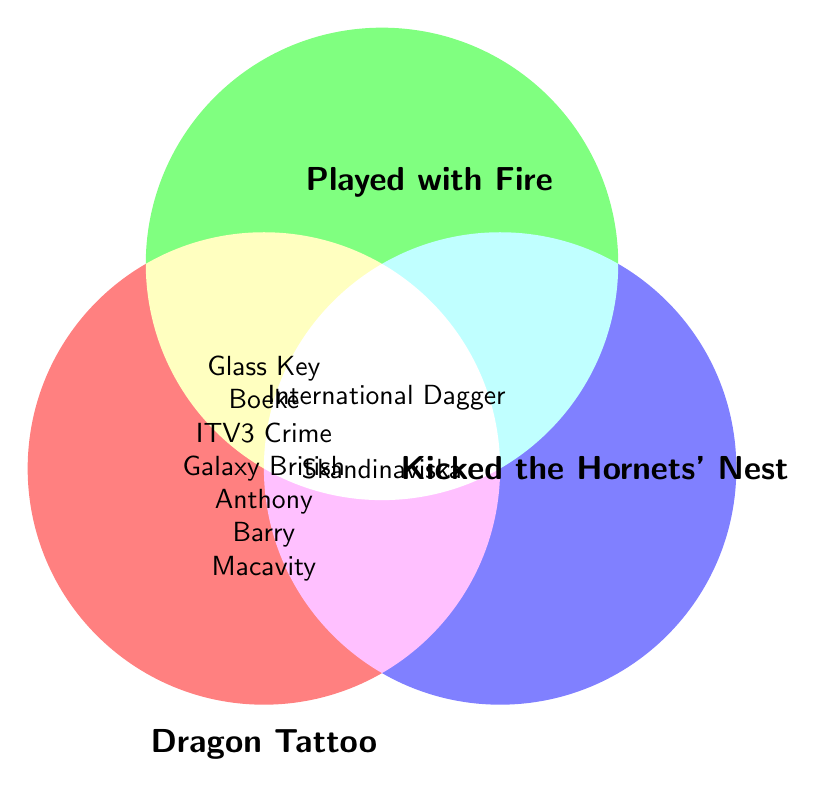What is the title of the book that won the Macavity Award? The Macavity Award is listed in the circle representing "The Girl with the Dragon Tattoo".
Answer: The Girl with the Dragon Tattoo Which award is represented by being in all three circles? The award in all three circles is positioned at the intersection of all three areas.
Answer: International Dagger Which book has won the most awards? By counting the unique awards listed in each circle, "The Girl with the Dragon Tattoo" has the most awards.
Answer: The Girl with the Dragon Tattoo Which book won the Skandinaviska Kriminalsällskapets Hederspris? The Skandinaviska Kriminalsällskapets Hederspris is listed only in the circle representing "The Girl Who Kicked the Hornets' Nest".
Answer: The Girl Who Kicked the Hornets' Nest How many awards did "The Girl Who Played with Fire" win? By counting the unique awards listed in the circle for "The Girl Who Played with Fire".
Answer: 2 Which book or books won the Galaxy British Book Awards? The Galaxy British Book Awards is listed in the circle for "The Girl with the Dragon Tattoo".
Answer: The Girl with the Dragon Tattoo Which books won the International Dagger award? The International Dagger is listed at the intersection of all three circles.
Answer: All three books What award did "The Girl with the Dragon Tattoo" and "The Girl Who Played with Fire" both win, but "The Girl Who Kicked the Hornets' Nest" did not? The award at the intersection of "The Girl with the Dragon Tattoo" and "The Girl Who Played with Fire" and not in "The Girl Who Kicked the Hornets' Nest" is the International Dagger.
Answer: International Dagger 